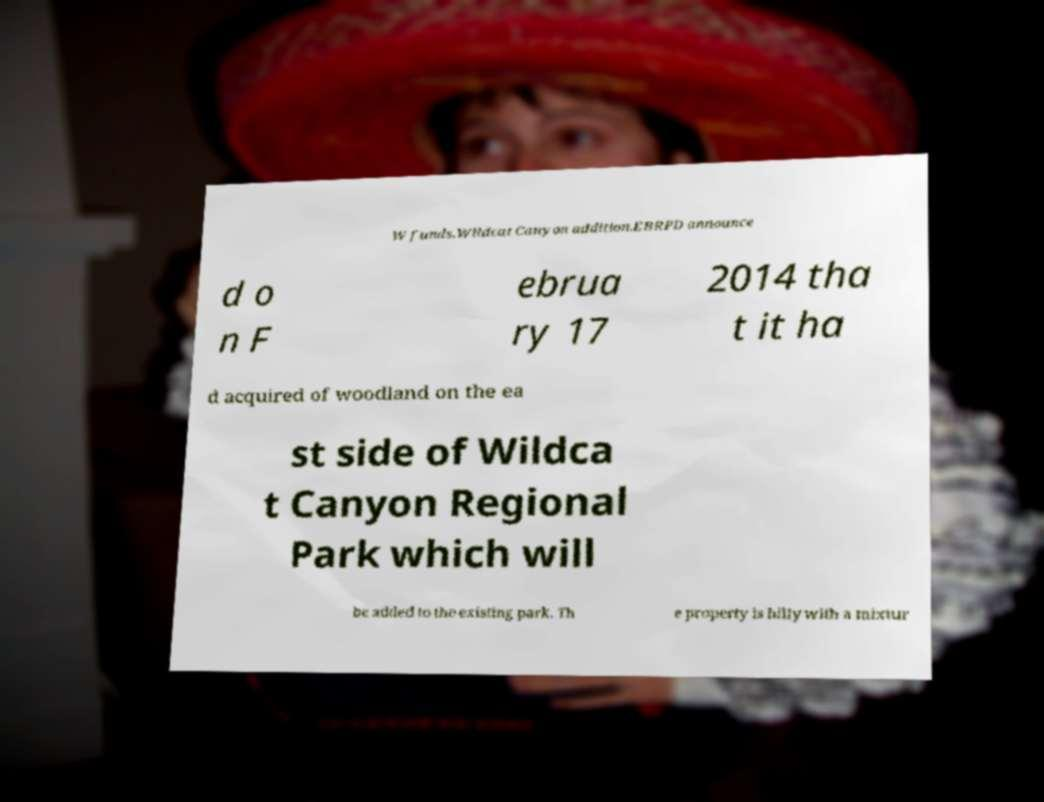For documentation purposes, I need the text within this image transcribed. Could you provide that? W funds.Wildcat Canyon addition.EBRPD announce d o n F ebrua ry 17 2014 tha t it ha d acquired of woodland on the ea st side of Wildca t Canyon Regional Park which will be added to the existing park. Th e property is hilly with a mixtur 